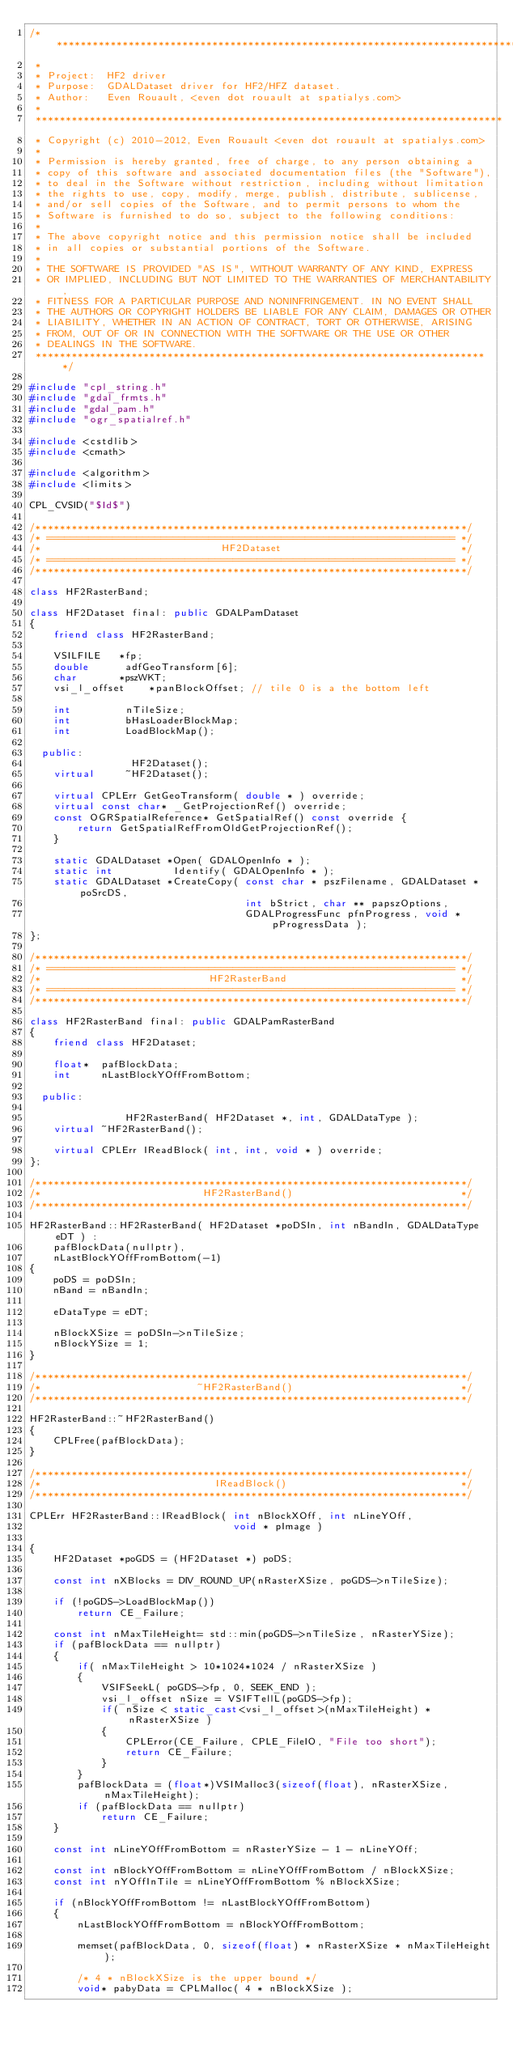Convert code to text. <code><loc_0><loc_0><loc_500><loc_500><_C++_>/******************************************************************************
 *
 * Project:  HF2 driver
 * Purpose:  GDALDataset driver for HF2/HFZ dataset.
 * Author:   Even Rouault, <even dot rouault at spatialys.com>
 *
 ******************************************************************************
 * Copyright (c) 2010-2012, Even Rouault <even dot rouault at spatialys.com>
 *
 * Permission is hereby granted, free of charge, to any person obtaining a
 * copy of this software and associated documentation files (the "Software"),
 * to deal in the Software without restriction, including without limitation
 * the rights to use, copy, modify, merge, publish, distribute, sublicense,
 * and/or sell copies of the Software, and to permit persons to whom the
 * Software is furnished to do so, subject to the following conditions:
 *
 * The above copyright notice and this permission notice shall be included
 * in all copies or substantial portions of the Software.
 *
 * THE SOFTWARE IS PROVIDED "AS IS", WITHOUT WARRANTY OF ANY KIND, EXPRESS
 * OR IMPLIED, INCLUDING BUT NOT LIMITED TO THE WARRANTIES OF MERCHANTABILITY,
 * FITNESS FOR A PARTICULAR PURPOSE AND NONINFRINGEMENT. IN NO EVENT SHALL
 * THE AUTHORS OR COPYRIGHT HOLDERS BE LIABLE FOR ANY CLAIM, DAMAGES OR OTHER
 * LIABILITY, WHETHER IN AN ACTION OF CONTRACT, TORT OR OTHERWISE, ARISING
 * FROM, OUT OF OR IN CONNECTION WITH THE SOFTWARE OR THE USE OR OTHER
 * DEALINGS IN THE SOFTWARE.
 ****************************************************************************/

#include "cpl_string.h"
#include "gdal_frmts.h"
#include "gdal_pam.h"
#include "ogr_spatialref.h"

#include <cstdlib>
#include <cmath>

#include <algorithm>
#include <limits>

CPL_CVSID("$Id$")

/************************************************************************/
/* ==================================================================== */
/*                              HF2Dataset                              */
/* ==================================================================== */
/************************************************************************/

class HF2RasterBand;

class HF2Dataset final: public GDALPamDataset
{
    friend class HF2RasterBand;

    VSILFILE   *fp;
    double      adfGeoTransform[6];
    char       *pszWKT;
    vsi_l_offset    *panBlockOffset; // tile 0 is a the bottom left

    int         nTileSize;
    int         bHasLoaderBlockMap;
    int         LoadBlockMap();

  public:
                 HF2Dataset();
    virtual     ~HF2Dataset();

    virtual CPLErr GetGeoTransform( double * ) override;
    virtual const char* _GetProjectionRef() override;
    const OGRSpatialReference* GetSpatialRef() const override {
        return GetSpatialRefFromOldGetProjectionRef();
    }

    static GDALDataset *Open( GDALOpenInfo * );
    static int          Identify( GDALOpenInfo * );
    static GDALDataset *CreateCopy( const char * pszFilename, GDALDataset *poSrcDS,
                                    int bStrict, char ** papszOptions,
                                    GDALProgressFunc pfnProgress, void * pProgressData );
};

/************************************************************************/
/* ==================================================================== */
/*                            HF2RasterBand                             */
/* ==================================================================== */
/************************************************************************/

class HF2RasterBand final: public GDALPamRasterBand
{
    friend class HF2Dataset;

    float*  pafBlockData;
    int     nLastBlockYOffFromBottom;

  public:

                HF2RasterBand( HF2Dataset *, int, GDALDataType );
    virtual ~HF2RasterBand();

    virtual CPLErr IReadBlock( int, int, void * ) override;
};

/************************************************************************/
/*                           HF2RasterBand()                            */
/************************************************************************/

HF2RasterBand::HF2RasterBand( HF2Dataset *poDSIn, int nBandIn, GDALDataType eDT ) :
    pafBlockData(nullptr),
    nLastBlockYOffFromBottom(-1)
{
    poDS = poDSIn;
    nBand = nBandIn;

    eDataType = eDT;

    nBlockXSize = poDSIn->nTileSize;
    nBlockYSize = 1;
}

/************************************************************************/
/*                          ~HF2RasterBand()                            */
/************************************************************************/

HF2RasterBand::~HF2RasterBand()
{
    CPLFree(pafBlockData);
}

/************************************************************************/
/*                             IReadBlock()                             */
/************************************************************************/

CPLErr HF2RasterBand::IReadBlock( int nBlockXOff, int nLineYOff,
                                  void * pImage )

{
    HF2Dataset *poGDS = (HF2Dataset *) poDS;

    const int nXBlocks = DIV_ROUND_UP(nRasterXSize, poGDS->nTileSize);

    if (!poGDS->LoadBlockMap())
        return CE_Failure;

    const int nMaxTileHeight= std::min(poGDS->nTileSize, nRasterYSize);
    if (pafBlockData == nullptr)
    {
        if( nMaxTileHeight > 10*1024*1024 / nRasterXSize )
        {
            VSIFSeekL( poGDS->fp, 0, SEEK_END );
            vsi_l_offset nSize = VSIFTellL(poGDS->fp);
            if( nSize < static_cast<vsi_l_offset>(nMaxTileHeight) * nRasterXSize )
            {
                CPLError(CE_Failure, CPLE_FileIO, "File too short");
                return CE_Failure;
            }
        }
        pafBlockData = (float*)VSIMalloc3(sizeof(float), nRasterXSize, nMaxTileHeight);
        if (pafBlockData == nullptr)
            return CE_Failure;
    }

    const int nLineYOffFromBottom = nRasterYSize - 1 - nLineYOff;

    const int nBlockYOffFromBottom = nLineYOffFromBottom / nBlockXSize;
    const int nYOffInTile = nLineYOffFromBottom % nBlockXSize;

    if (nBlockYOffFromBottom != nLastBlockYOffFromBottom)
    {
        nLastBlockYOffFromBottom = nBlockYOffFromBottom;

        memset(pafBlockData, 0, sizeof(float) * nRasterXSize * nMaxTileHeight);

        /* 4 * nBlockXSize is the upper bound */
        void* pabyData = CPLMalloc( 4 * nBlockXSize );
</code> 